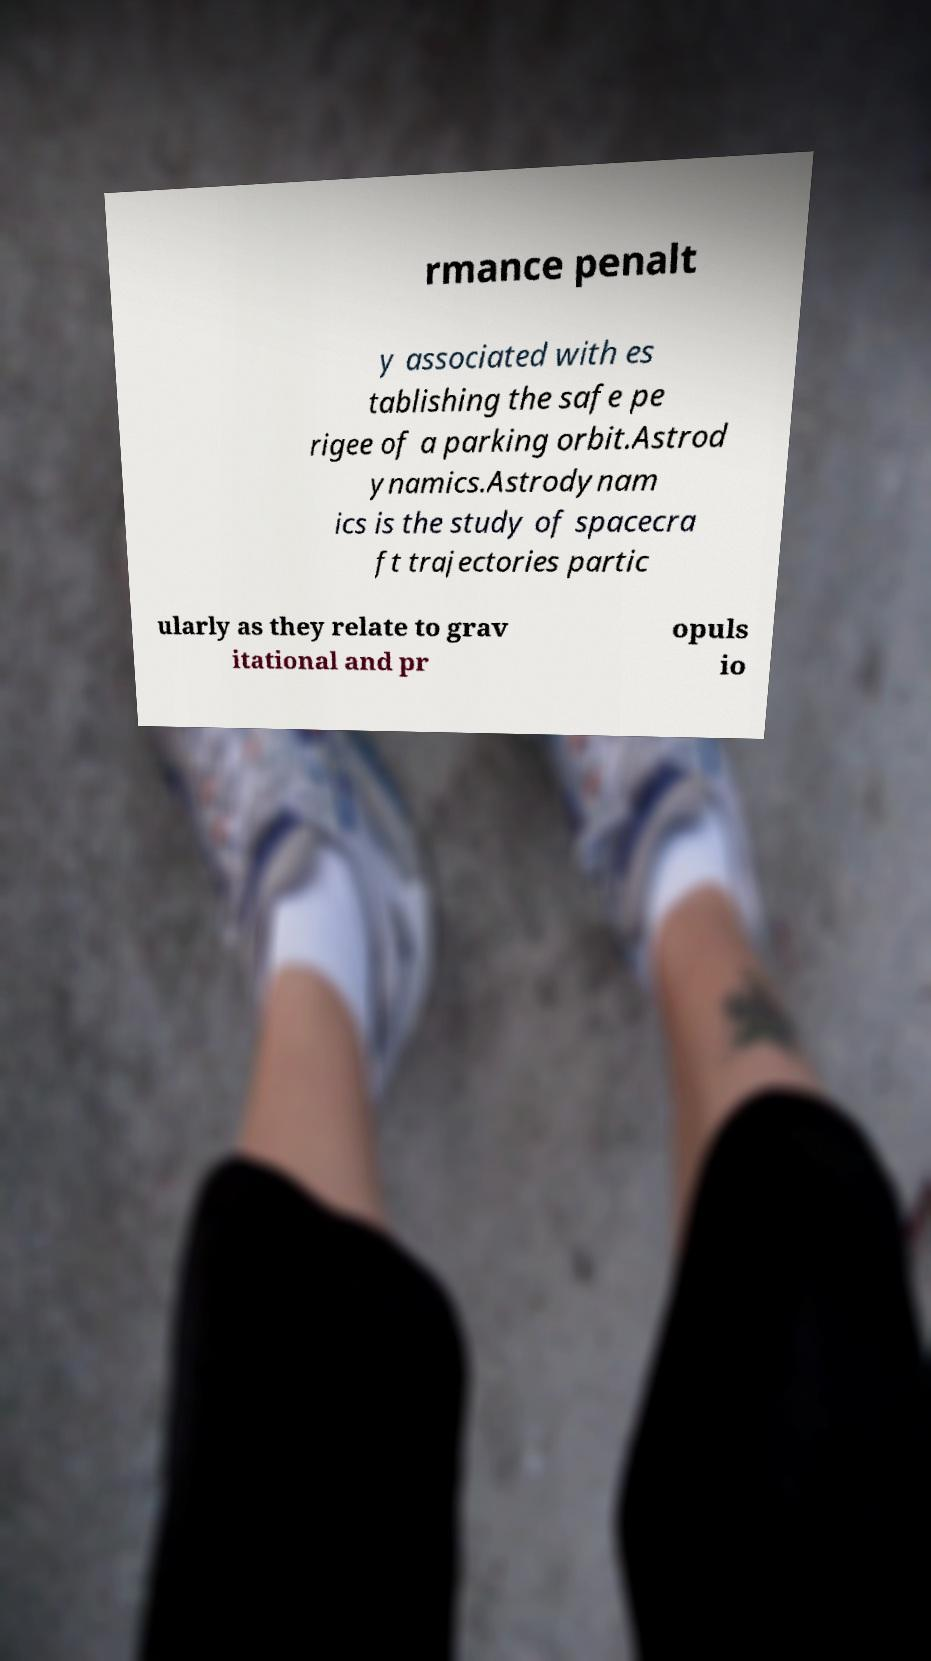Can you read and provide the text displayed in the image?This photo seems to have some interesting text. Can you extract and type it out for me? rmance penalt y associated with es tablishing the safe pe rigee of a parking orbit.Astrod ynamics.Astrodynam ics is the study of spacecra ft trajectories partic ularly as they relate to grav itational and pr opuls io 